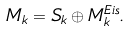<formula> <loc_0><loc_0><loc_500><loc_500>M _ { k } = S _ { k } \oplus M _ { k } ^ { E i s } .</formula> 